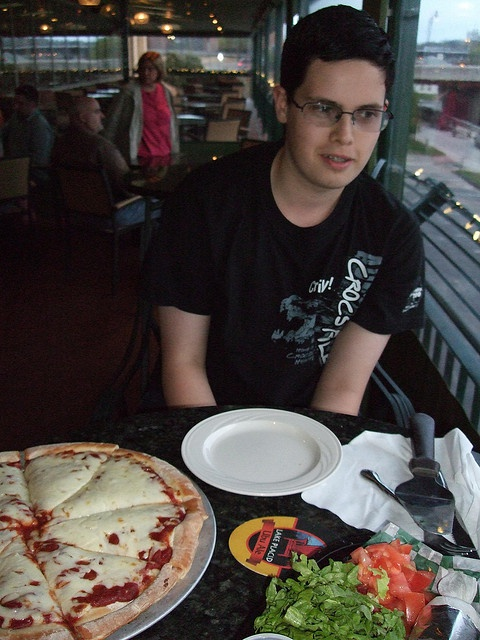Describe the objects in this image and their specific colors. I can see people in black, gray, and maroon tones, pizza in black, darkgray, tan, gray, and maroon tones, dining table in black, darkgray, gray, and lightgray tones, people in black, maroon, gray, and brown tones, and people in black, navy, and gray tones in this image. 